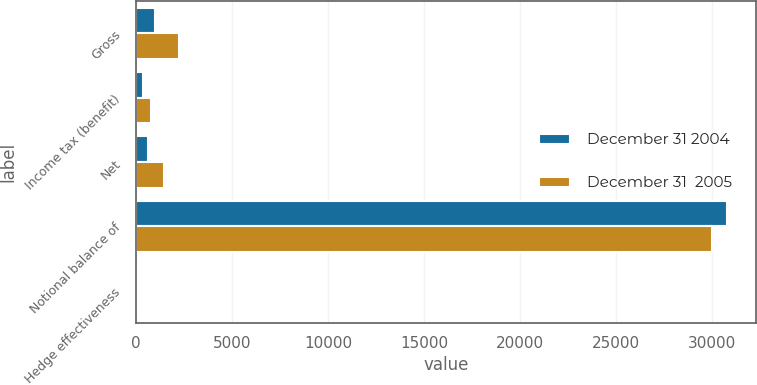Convert chart to OTSL. <chart><loc_0><loc_0><loc_500><loc_500><stacked_bar_chart><ecel><fcel>Gross<fcel>Income tax (benefit)<fcel>Net<fcel>Notional balance of<fcel>Hedge effectiveness<nl><fcel>December 31 2004<fcel>999<fcel>376<fcel>623<fcel>30750<fcel>100<nl><fcel>December 31  2005<fcel>2231<fcel>781<fcel>1450<fcel>30000<fcel>100<nl></chart> 